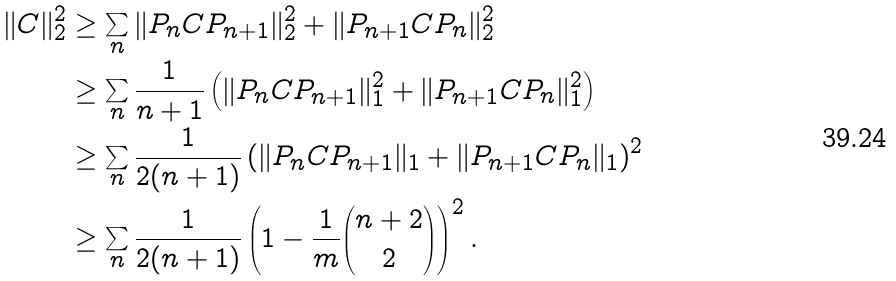Convert formula to latex. <formula><loc_0><loc_0><loc_500><loc_500>\| C \| _ { 2 } ^ { 2 } & \geq \sum _ { n } \| P _ { n } C P _ { n + 1 } \| _ { 2 } ^ { 2 } + \| P _ { n + 1 } C P _ { n } \| _ { 2 } ^ { 2 } \\ & \geq \sum _ { n } \frac { 1 } { n + 1 } \left ( \| P _ { n } C P _ { n + 1 } \| _ { 1 } ^ { 2 } + \| P _ { n + 1 } C P _ { n } \| _ { 1 } ^ { 2 } \right ) \\ & \geq \sum _ { n } \frac { 1 } { 2 ( n + 1 ) } \left ( \| P _ { n } C P _ { n + 1 } \| _ { 1 } + \| P _ { n + 1 } C P _ { n } \| _ { 1 } \right ) ^ { 2 } \\ & \geq \sum _ { n } \frac { 1 } { 2 ( n + 1 ) } \left ( 1 - \frac { 1 } { m } \binom { n + 2 } { 2 } \right ) ^ { 2 } .</formula> 